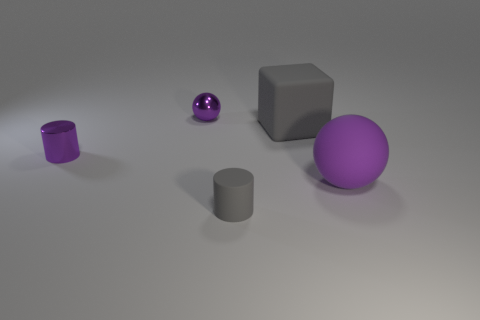Add 1 tiny purple objects. How many objects exist? 6 Subtract all gray cylinders. How many cylinders are left? 1 Subtract 2 spheres. How many spheres are left? 0 Subtract all cylinders. How many objects are left? 3 Subtract all purple cubes. How many purple cylinders are left? 1 Subtract all small gray rubber cylinders. Subtract all big purple matte things. How many objects are left? 3 Add 4 big rubber spheres. How many big rubber spheres are left? 5 Add 1 big purple spheres. How many big purple spheres exist? 2 Subtract 0 red spheres. How many objects are left? 5 Subtract all red cubes. Subtract all gray cylinders. How many cubes are left? 1 